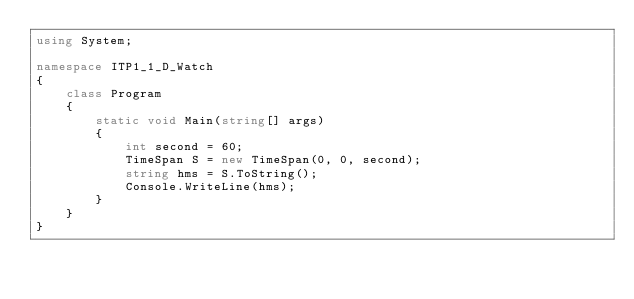<code> <loc_0><loc_0><loc_500><loc_500><_C#_>using System;

namespace ITP1_1_D_Watch
{
    class Program
    {
        static void Main(string[] args)
        {
            int second = 60;
            TimeSpan S = new TimeSpan(0, 0, second);
            string hms = S.ToString();
            Console.WriteLine(hms);
        }
    }
}

</code> 